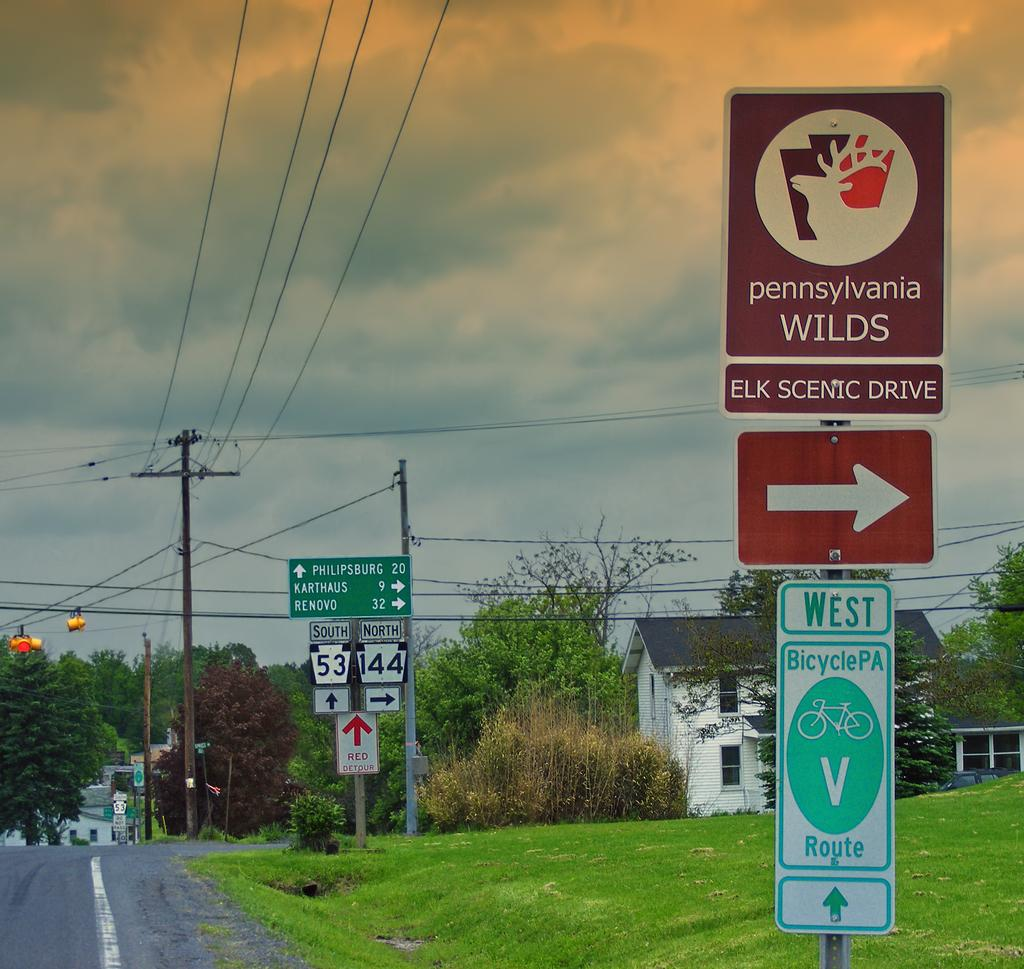<image>
Describe the image concisely. If you take a right there will be the Elk Scenic Drive 